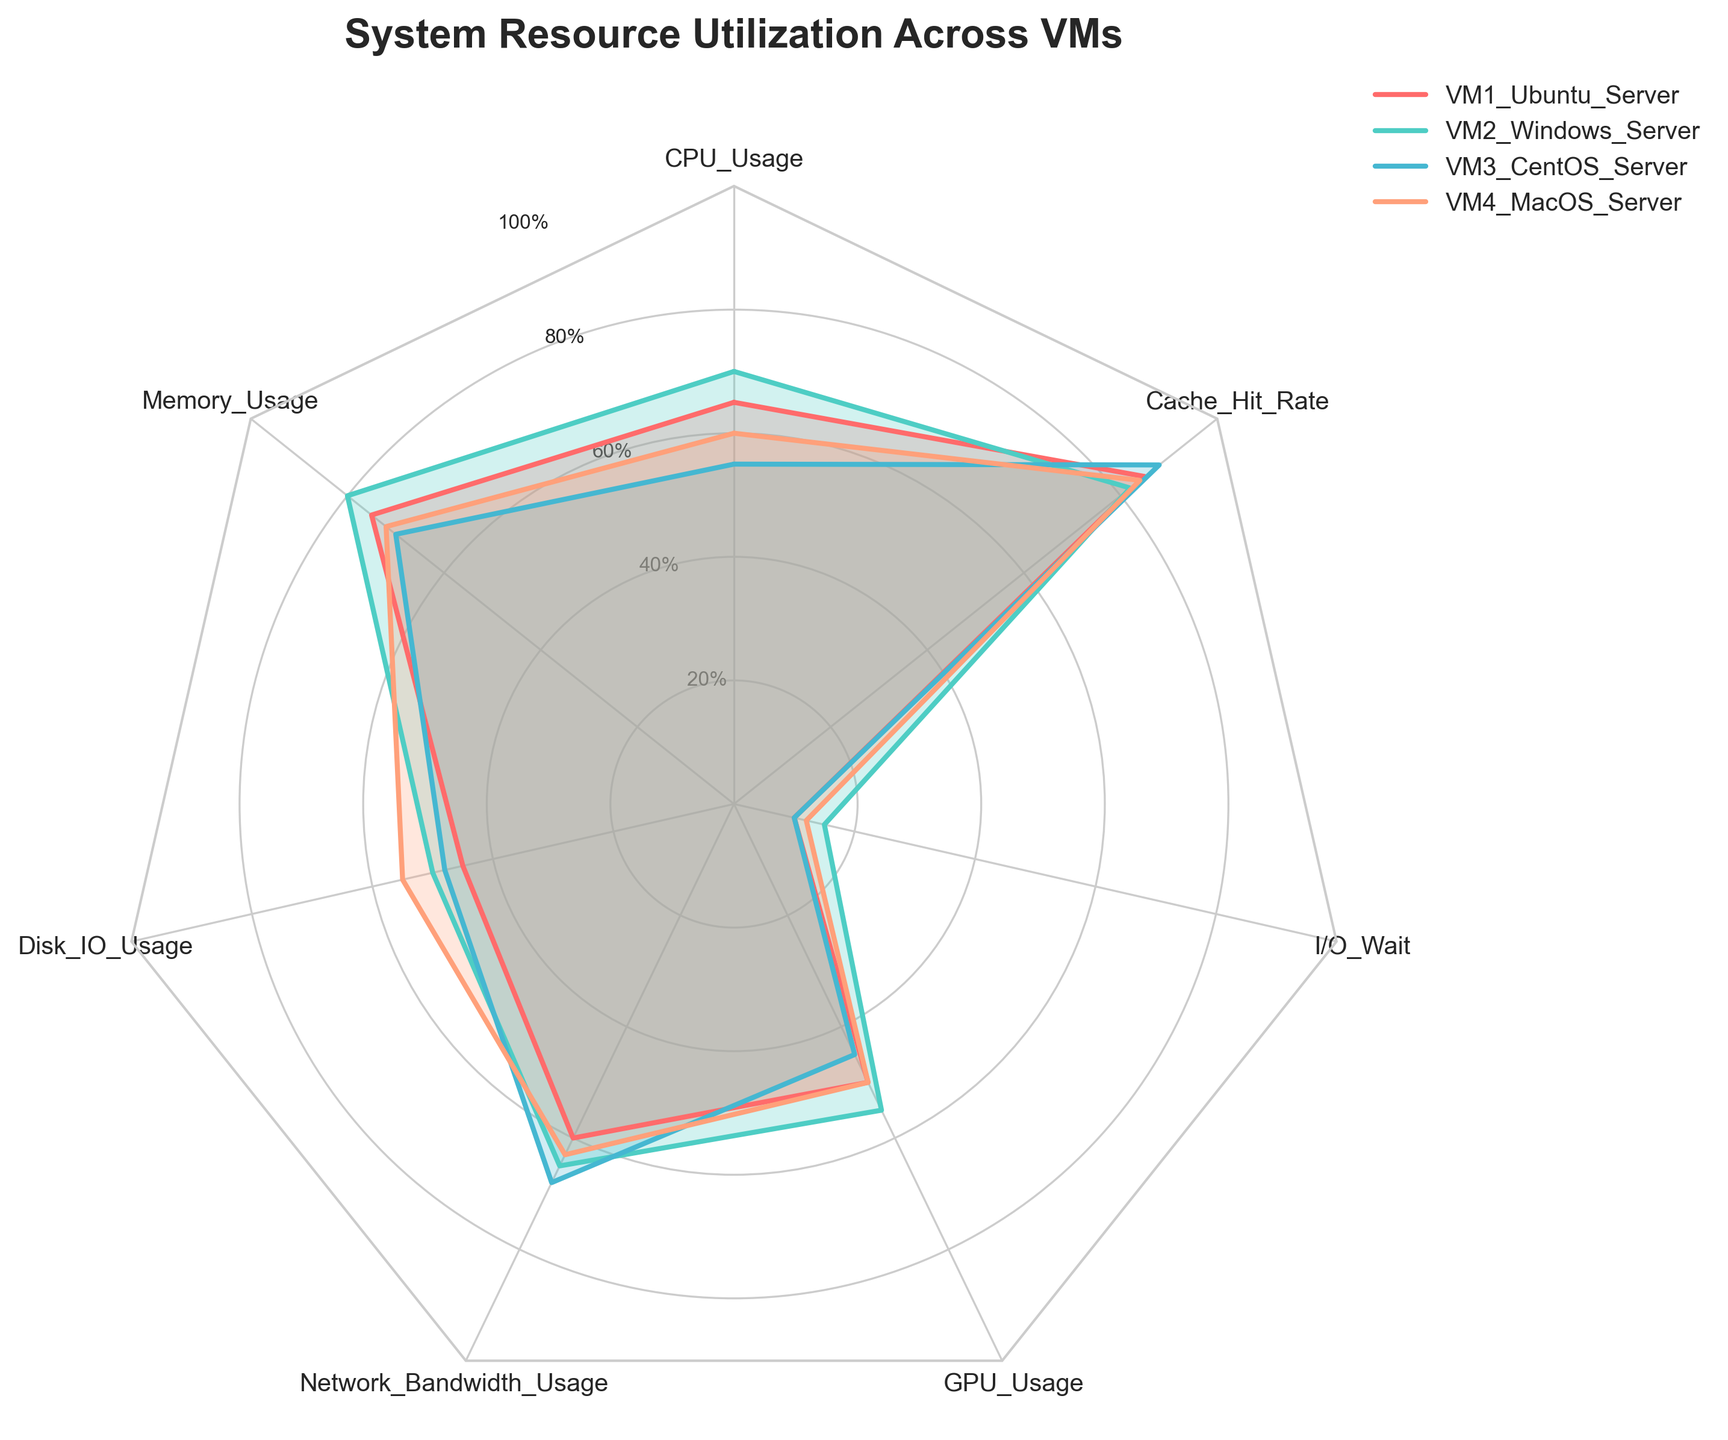What is the title of the chart? The title is displayed prominently at the top of the chart, and it is typically straightforward and directly states the purpose of the chart.
Answer: System Resource Utilization Across VMs Which VM shows the highest CPU usage? The CPU usage can be determined by looking at the first segment of the radar chart and identifying which line extends the furthest. In this case, the line for VM2 Windows Server extends the furthest, indicating the highest CPU usage.
Answer: VM2 Windows Server Which VM has the lowest I/O Wait time? To find the VM with the lowest I/O Wait, look at the segment labeled "I/O Wait" and identify which line is the closest to the center of the radar chart. Here, both VM1 Ubuntu Server and VM3 CentOS Server have the lowest I/O Wait time of 10%.
Answer: VM1 Ubuntu Server, VM3 CentOS Server Compare the Memory Usage across the VMs. Which VM uses the most memory and by what percentage? By examining the second segment for Memory Usage, the line for VM2 Windows Server extends the furthest, indicating it has the highest Memory Usage at 80%.
Answer: VM2 Windows Server, 80% What is the average GPU usage across all VMs? To calculate the average, add the GPU usage percentages for all VMs and divide by the number of VMs (50 + 55 + 45 + 50) / 4 = 200 / 4.
Answer: 50% Which resource utilization demonstrates the least variability among the VMs? By looking at the compactness of the lines for each resource segment, the "Cache Hit Rate" segment shows lines that are the closest to one another (85, 82, 88, 84), indicating the least variability.
Answer: Cache Hit Rate How does VM4 MacOS Server compare to VM3 CentOS Server in terms of Network Bandwidth Usage? Look at the Network Bandwidth Usage segment and compare the lines for VM4 MacOS Server and VM3 CentOS Server. VM4 MacOS Server has a value of 63%, whereas VM3 CentOS Server has 68%, showing that VM3 utilizes more bandwidth.
Answer: VM3 CentOS Server has higher Network Bandwidth Usage Considering all resources, which VM demonstrates the most balanced resource utilization? By analyzing the overall shape and spread of each VM's line across the radar chart, VM1 Ubuntu Server appears to have a more balanced utilization with no extreme highs or lows compared to others.
Answer: VM1 Ubuntu Server If we combine CPU and Memory Usage, which VM exhibits the highest combined utilization and by how much? Combining CPU and Memory usage values for each VM, VM2 Windows Server has the highest combined utilization (70 + 80 = 150%). This can be confirmed by comparing the sums of each VM.
Answer: VM2 Windows Server, 150% 